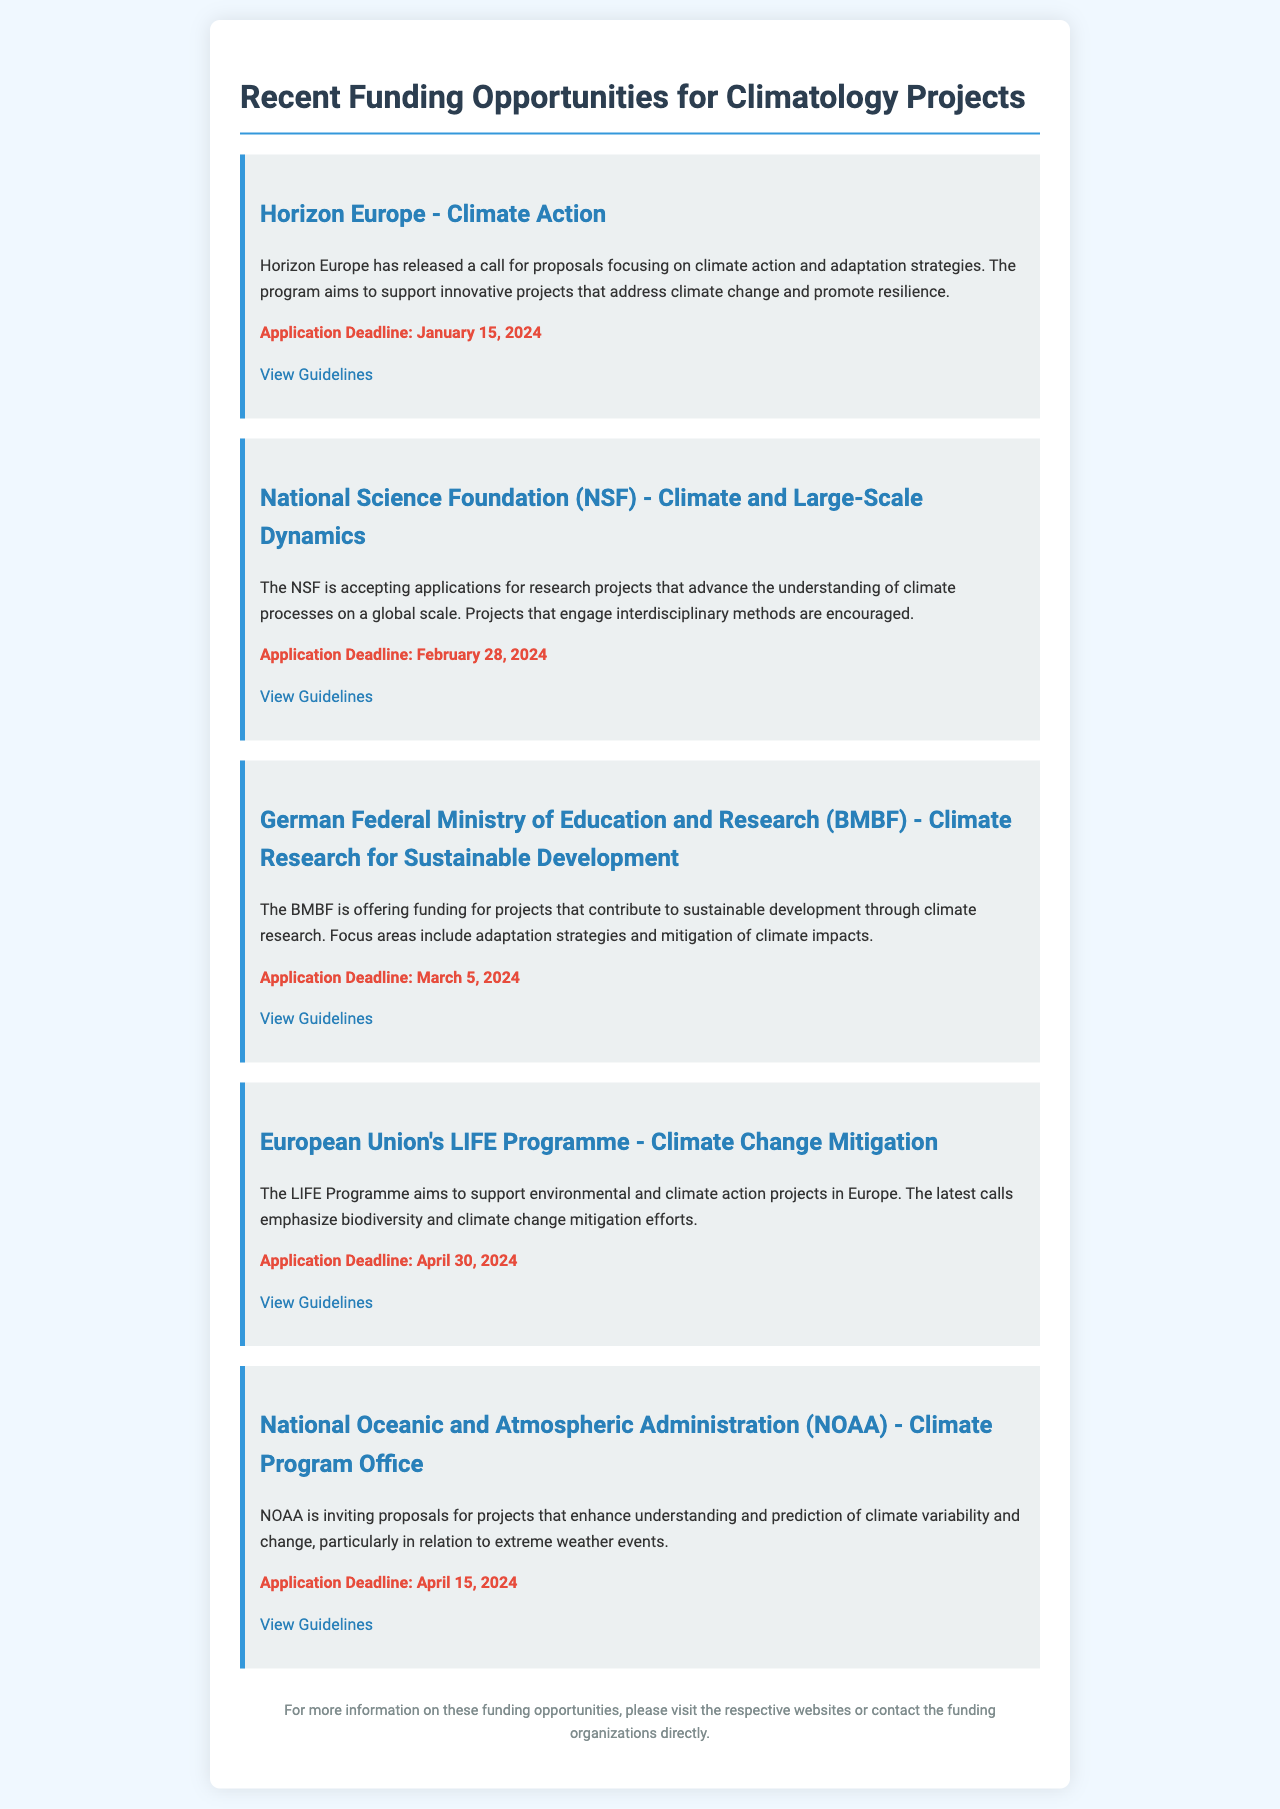What is the application deadline for Horizon Europe? The application deadline for Horizon Europe is explicitly stated in the document as January 15, 2024.
Answer: January 15, 2024 What is the focus area of the BMBF funding opportunity? The document describes that the BMBF funding opportunity focuses on climate research for sustainable development, including adaptation strategies and mitigation of climate impacts.
Answer: Sustainable development Which organization is offering funding for climate and large-scale dynamics research? The document identifies the National Science Foundation (NSF) as the organization accepting applications for climate and large-scale dynamics research.
Answer: National Science Foundation (NSF) How many funding opportunities are listed in the document? The total number of funding opportunities presented in the document can be counted from the sections detailing each opportunity, which totals five.
Answer: Five What is the main objective of NOAA's funding program? The document specifies that NOAA's program aims to enhance understanding and prediction of climate variability and change, particularly regarding extreme weather events.
Answer: Understanding climate variability What is the latest application deadline mentioned in the document? The latest application deadline is for the European Union's LIFE Programme with a specified application deadline of April 30, 2024, making it the most distant upcoming deadline.
Answer: April 30, 2024 Which funding opportunity is focused on projects that emphasize biodiversity? The document mentions that the European Union's LIFE Programme emphasizes biodiversity and climate change mitigation efforts among its objectives.
Answer: European Union's LIFE Programme What type of projects does the NSF encourage? The document states that the NSF encourages projects that engage interdisciplinary methods in understanding climate processes on a global scale.
Answer: Interdisciplinary methods 